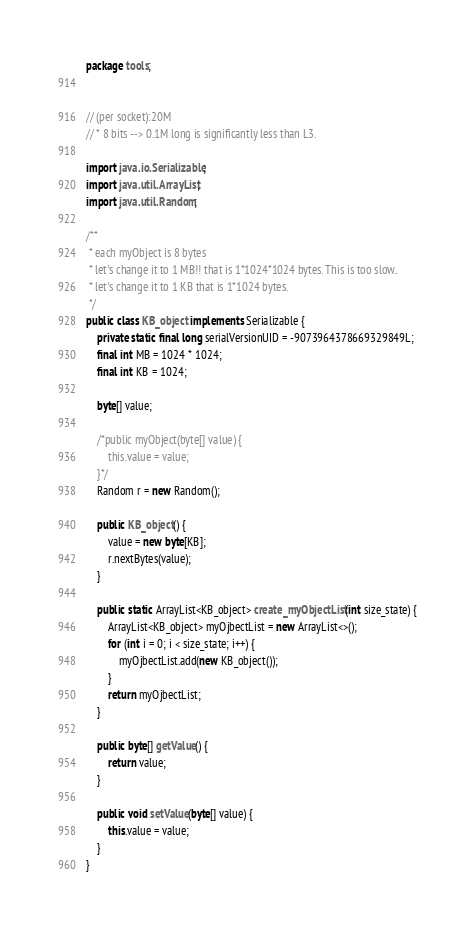<code> <loc_0><loc_0><loc_500><loc_500><_Java_>package tools;


// (per socket):20M
// * 8 bits --> 0.1M long is significantly less than L3.

import java.io.Serializable;
import java.util.ArrayList;
import java.util.Random;

/**
 * each myObject is 8 bytes
 * let's change it to 1 MB!! that is 1*1024*1024 bytes. This is too slow..
 * let's change it to 1 KB that is 1*1024 bytes.
 */
public class KB_object implements Serializable {
    private static final long serialVersionUID = -9073964378669329849L;
    final int MB = 1024 * 1024;
    final int KB = 1024;

    byte[] value;

    /*public myObject(byte[] value) {
        this.value = value;
    }*/
    Random r = new Random();

    public KB_object() {
        value = new byte[KB];
        r.nextBytes(value);
    }

    public static ArrayList<KB_object> create_myObjectList(int size_state) {
        ArrayList<KB_object> myOjbectList = new ArrayList<>();
        for (int i = 0; i < size_state; i++) {
            myOjbectList.add(new KB_object());
        }
        return myOjbectList;
    }

    public byte[] getValue() {
        return value;
    }

    public void setValue(byte[] value) {
        this.value = value;
    }
}
</code> 